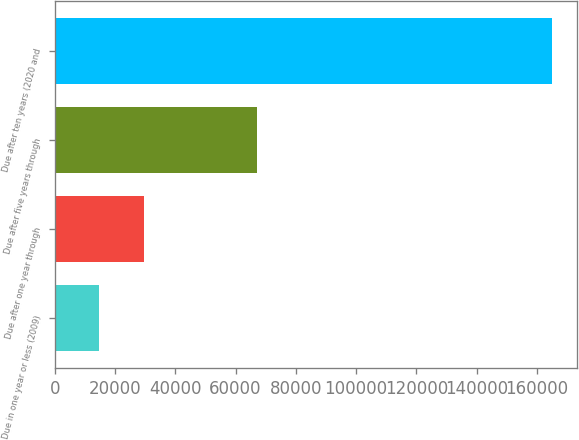<chart> <loc_0><loc_0><loc_500><loc_500><bar_chart><fcel>Due in one year or less (2009)<fcel>Due after one year through<fcel>Due after five years through<fcel>Due after ten years (2020 and<nl><fcel>14675<fcel>29714.8<fcel>67037<fcel>165073<nl></chart> 